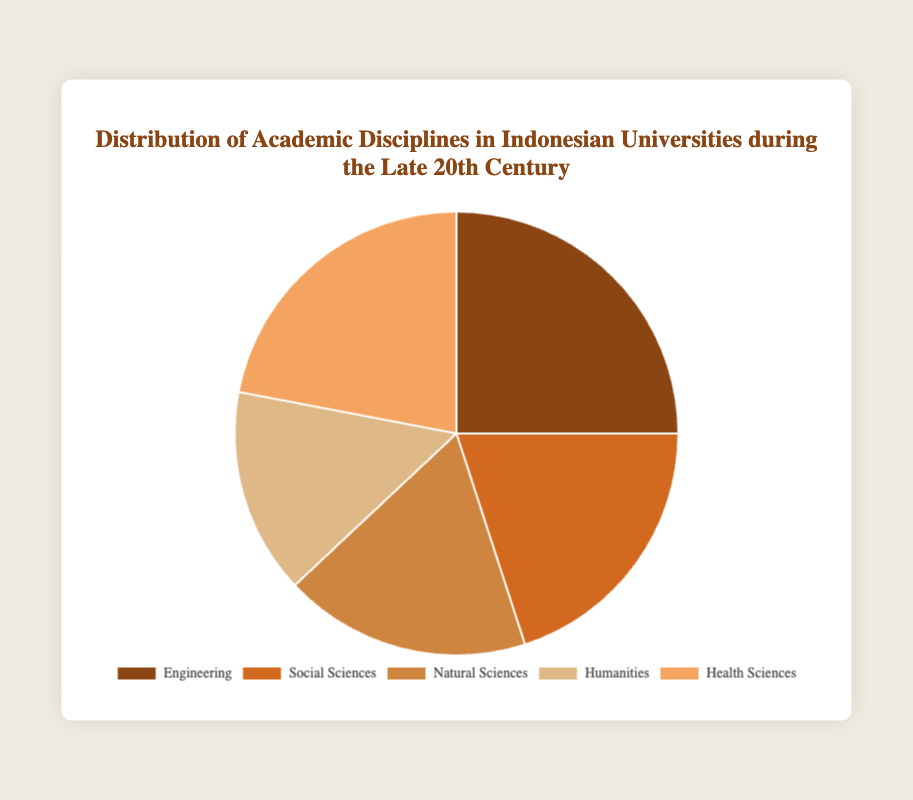What percentage of Indonesian university students were enrolled in Engineering during the late 20th century? The figure shows that Engineering represents 25% of the disciplines in Indonesian universities.
Answer: 25% Which discipline had a larger share of students, Health Sciences or Social Sciences? Health Sciences had a 22% share, while Social Sciences had a 20% share. Therefore, Health Sciences had a larger share.
Answer: Health Sciences By how much did the percentage of students in Natural Sciences differ from those in Humanities? The percentage for Natural Sciences is 18%, and for Humanities, it is 15%. The difference is 18% - 15% = 3%.
Answer: 3% What is the total percentage of students in Social Sciences and Humanities combined? Social Sciences have 20% and Humanities have 15%. The combined total is 20% + 15% = 35%.
Answer: 35% Which academic discipline had the lowest enrollment percentage? According to the figure, Humanities had the lowest enrollment percentage at 15%.
Answer: Humanities Rank the disciplines in descending order based on their percentage share. The disciplines can be ordered as follows: Engineering (25%), Health Sciences (22%), Social Sciences (20%), Natural Sciences (18%), Humanities (15%).
Answer: Engineering, Health Sciences, Social Sciences, Natural Sciences, Humanities What is the average percentage of students enrolled in Health Sciences and Natural Sciences? Health Sciences have 22% and Natural Sciences have 18%. The average is (22% + 18%) / 2 = 20%.
Answer: 20% Which two disciplines combined account for nearly half the percentage of students? Engineering (25%) and Health Sciences (22%) combined give 25% + 22% = 47%, which is nearly half.
Answer: Engineering and Health Sciences Did more students enroll in Engineering or in Humanities and Natural Sciences combined? Engineering has 25%. Humanities and Natural Sciences together have 15% + 18% = 33%. Therefore, more students enrolled in Humanities and Natural Sciences combined.
Answer: Humanities and Natural Sciences combined 